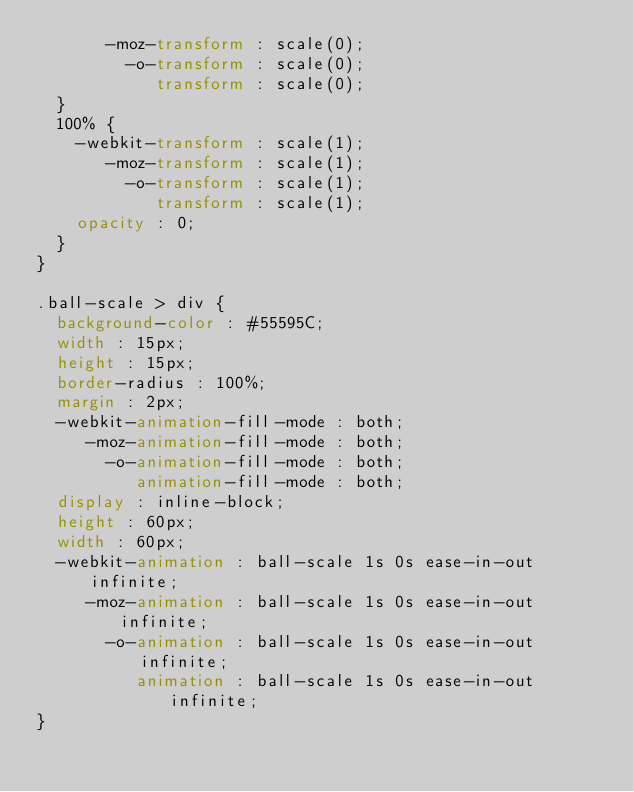<code> <loc_0><loc_0><loc_500><loc_500><_CSS_>       -moz-transform : scale(0);
         -o-transform : scale(0);
            transform : scale(0);
  }
  100% {
    -webkit-transform : scale(1);
       -moz-transform : scale(1);
         -o-transform : scale(1);
            transform : scale(1);
    opacity : 0;
  }
}

.ball-scale > div {
  background-color : #55595C;
  width : 15px;
  height : 15px;
  border-radius : 100%;
  margin : 2px;
  -webkit-animation-fill-mode : both;
     -moz-animation-fill-mode : both;
       -o-animation-fill-mode : both;
          animation-fill-mode : both;
  display : inline-block;
  height : 60px;
  width : 60px;
  -webkit-animation : ball-scale 1s 0s ease-in-out infinite;
     -moz-animation : ball-scale 1s 0s ease-in-out infinite;
       -o-animation : ball-scale 1s 0s ease-in-out infinite;
          animation : ball-scale 1s 0s ease-in-out infinite;
}</code> 